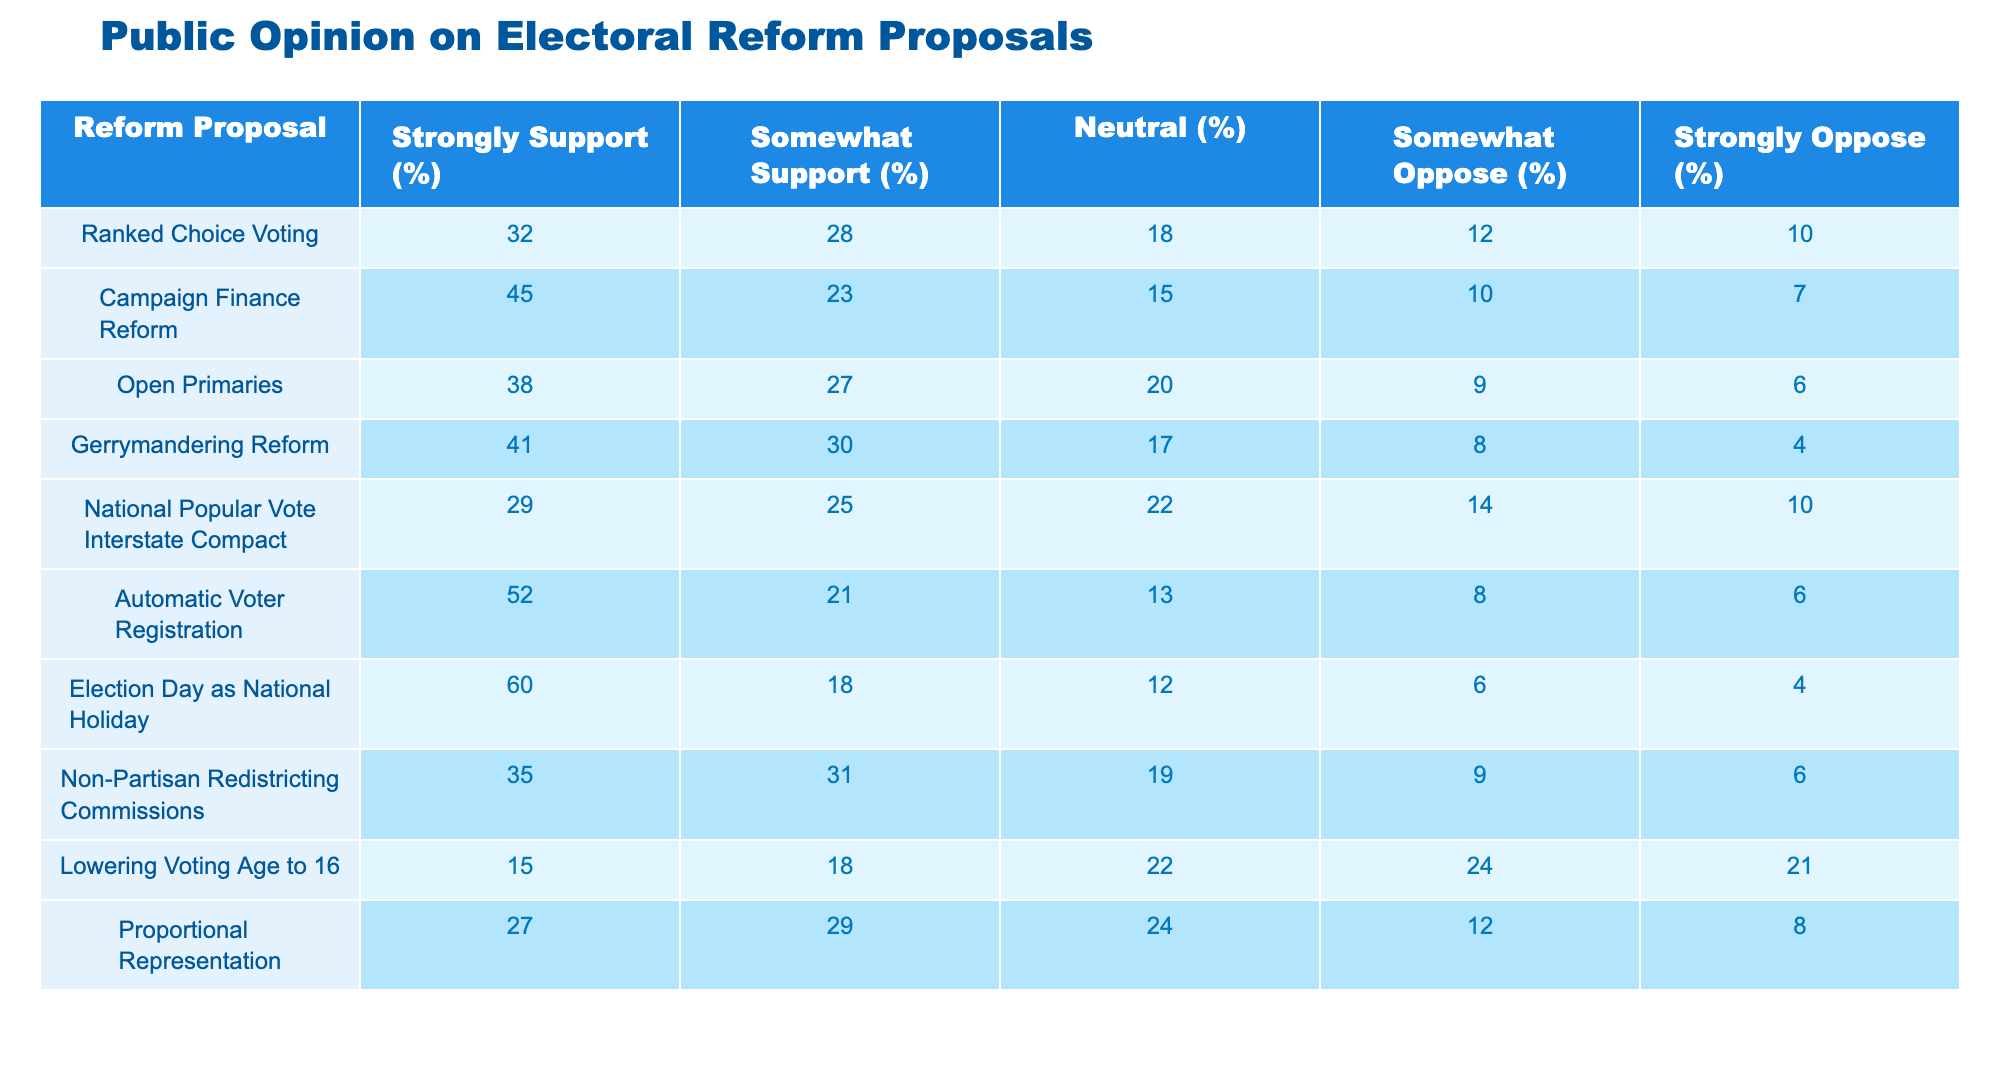What percentage of people strongly support Election Day as a National Holiday? The table shows that 60% of respondents strongly support making Election Day a National Holiday. This is directly stated in the corresponding row for this proposal under the "Strongly Support (%)" column.
Answer: 60% Which reform proposal has the highest percentage of strong support? By comparing the "Strongly Support (%)" values across all proposals, it's clear that the proposal with the highest percentage is "Election Day as National Holiday" at 60%. This is found by checking all values in that column.
Answer: Election Day as National Holiday What is the total percentage of people who oppose Campaign Finance Reform? The total opposition percentage is calculated by adding the "Somewhat Oppose (%)" and "Strongly Oppose (%)" percentages for Campaign Finance Reform. So, 10% + 7% = 17%. This involves a simple sum of the two relevant columns.
Answer: 17% Is it true that more people support Open Primaries than strongly oppose it? Looking at the "Somewhat Support (%)" which is 27% and the combined opposition which is 9% + 6% = 15%, it's evident that support (27%) exceeds opposition (15%). To determine if the statement is true, we compare these two values.
Answer: Yes What is the difference between the percentage of strong support for Automatic Voter Registration and Ranked Choice Voting? To find the difference, subtract the strong support percentage for Ranked Choice Voting (32%) from that of Automatic Voter Registration (52%). The calculation is 52% - 32% = 20%. This involves simply performing a subtraction operation between the two values.
Answer: 20% What percentage of people are neutral towards Proportional Representation? The table indicates that 24% of people selected "Neutral (%)" for Proportional Representation. This value can be found directly in the "Neutral (%)" column corresponding to this proposal.
Answer: 24% What is the average percentage of strong support for the top three reform proposals? The top three proposals based on strong support percentages are Election Day as National Holiday (60%), Automatic Voter Registration (52%), and Campaign Finance Reform (45%). To find the average, add them (60 + 52 + 45 = 157) and divide by 3, resulting in an average of 52.33%. This involves summing and then averaging the values.
Answer: 52.33% Are more people neutral about lowering the voting age to 16 than strongly oppose it? The neutral percentage for lowering the voting age is 22% and the strong opposition percentage is 21%. Since 22% (neutral) is greater than 21% (strongly opposed), the answer is yes. A simple comparison determines the answer.
Answer: Yes 